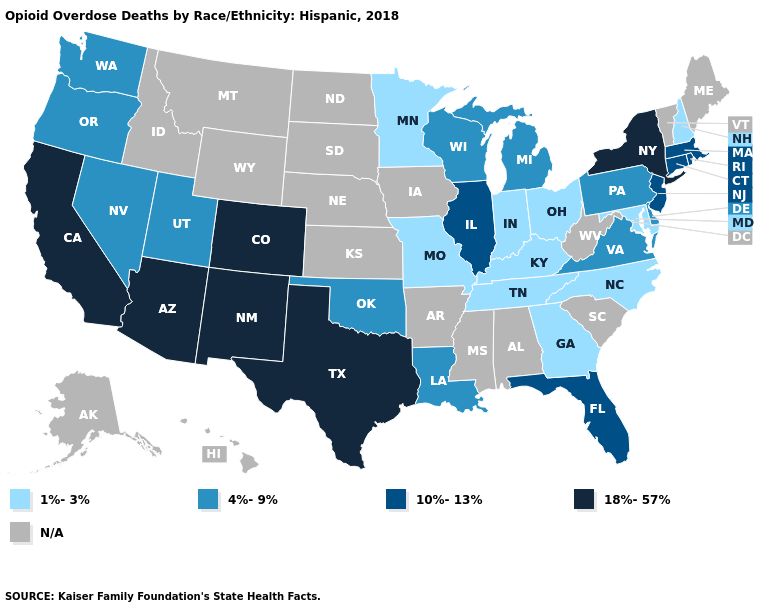What is the value of Tennessee?
Be succinct. 1%-3%. Which states hav the highest value in the West?
Keep it brief. Arizona, California, Colorado, New Mexico. Which states hav the highest value in the South?
Quick response, please. Texas. Among the states that border Massachusetts , which have the lowest value?
Give a very brief answer. New Hampshire. Among the states that border New Mexico , does Utah have the lowest value?
Write a very short answer. Yes. What is the value of Kentucky?
Be succinct. 1%-3%. What is the value of Oregon?
Be succinct. 4%-9%. Name the states that have a value in the range 1%-3%?
Give a very brief answer. Georgia, Indiana, Kentucky, Maryland, Minnesota, Missouri, New Hampshire, North Carolina, Ohio, Tennessee. What is the lowest value in the West?
Answer briefly. 4%-9%. How many symbols are there in the legend?
Give a very brief answer. 5. What is the lowest value in the MidWest?
Keep it brief. 1%-3%. Which states have the lowest value in the West?
Write a very short answer. Nevada, Oregon, Utah, Washington. What is the highest value in states that border Nebraska?
Write a very short answer. 18%-57%. What is the value of Louisiana?
Keep it brief. 4%-9%. 